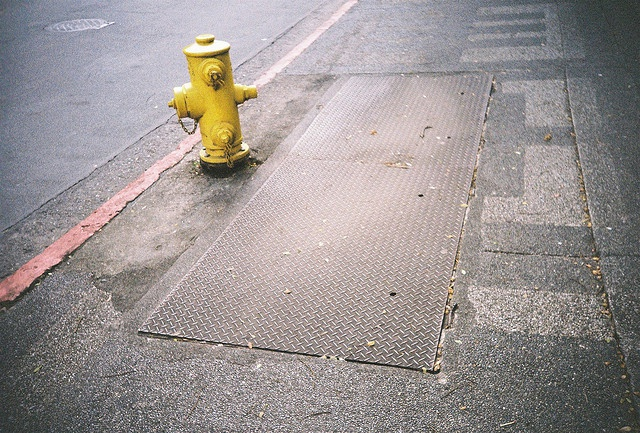Describe the objects in this image and their specific colors. I can see a fire hydrant in gray, gold, olive, and ivory tones in this image. 